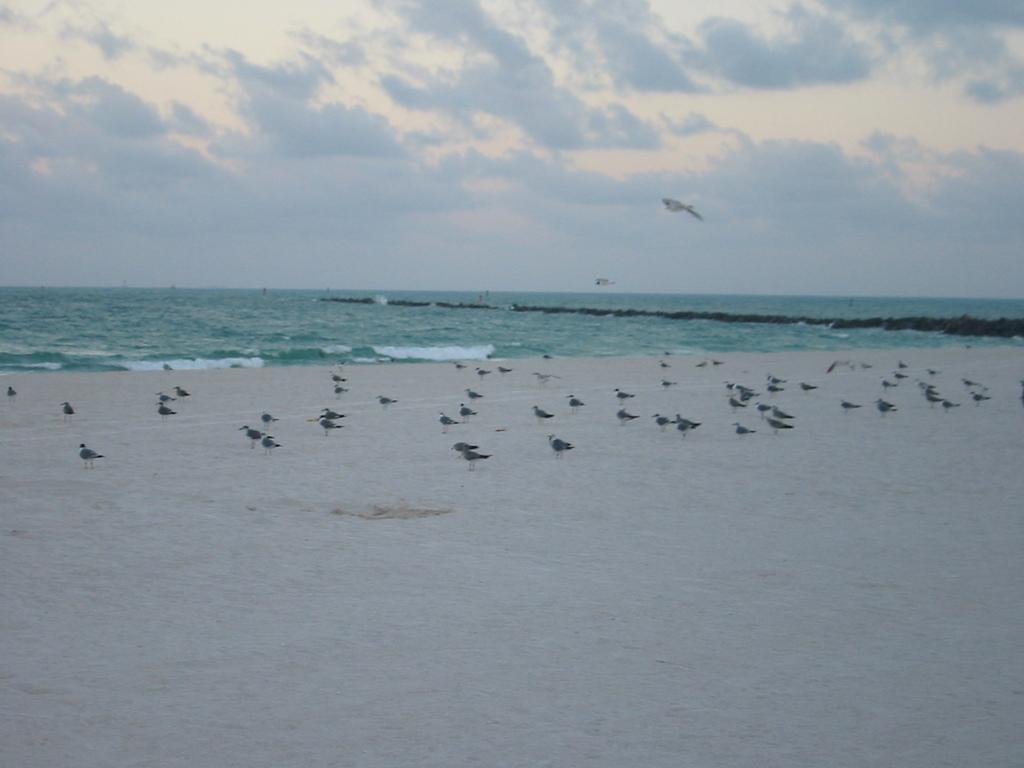Please provide a concise description of this image. In this image we can see some birds which are on sand at the beach and in the background of the image there is water and cloudy sky. 